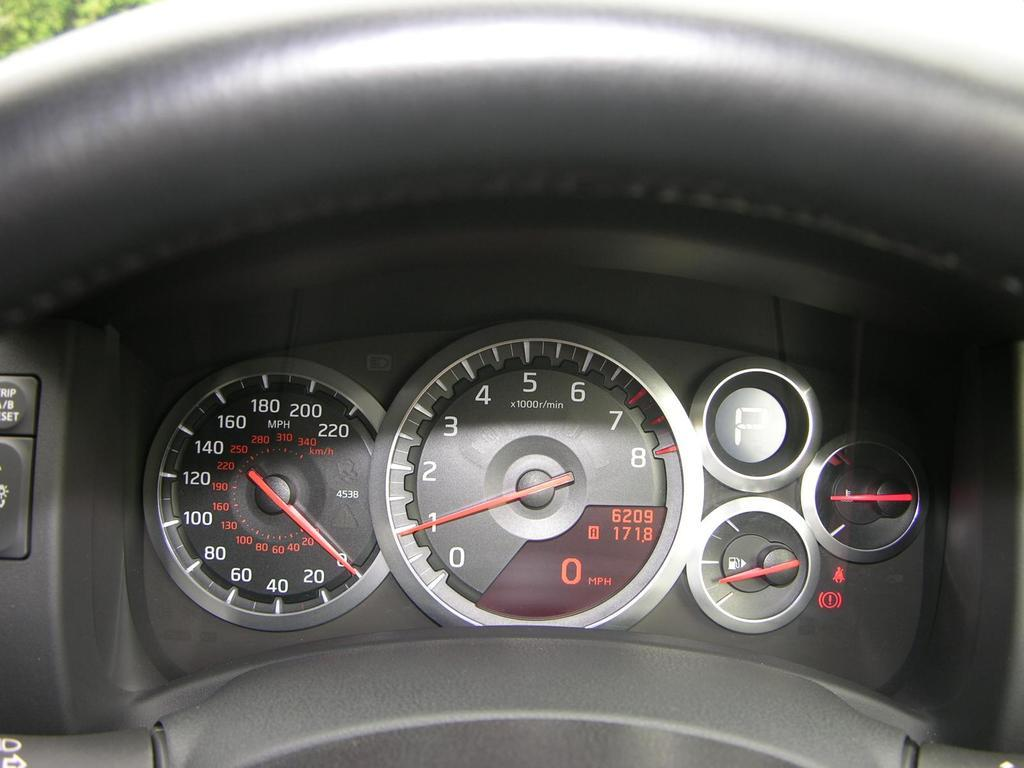What is the main object in the image? There is a steering wheel in the image. What is the color of the steering wheel? The steering wheel is black in color. What other instrument is visible in the image? There is a speedometer in the image. What device is used to monitor the fuel level? There is a fuel indicator meter in the image. What army invention is depicted in the image? There is no army invention depicted in the image; it features a steering wheel, speedometer, and fuel indicator meter. What decision is being made in the image? There is no decision being made in the image; it shows various instruments related to a vehicle. 